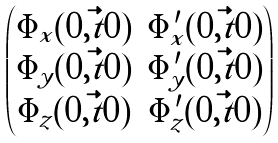Convert formula to latex. <formula><loc_0><loc_0><loc_500><loc_500>\begin{pmatrix} \Phi _ { x } ( 0 , \vec { t } { 0 } ) & \Phi ^ { \prime } _ { x } ( 0 , \vec { t } { 0 } ) \\ \Phi _ { y } ( 0 , \vec { t } { 0 } ) & \Phi ^ { \prime } _ { y } ( 0 , \vec { t } { 0 } ) \\ \Phi _ { z } ( 0 , \vec { t } { 0 } ) & \Phi ^ { \prime } _ { z } ( 0 , \vec { t } { 0 } ) \end{pmatrix}</formula> 